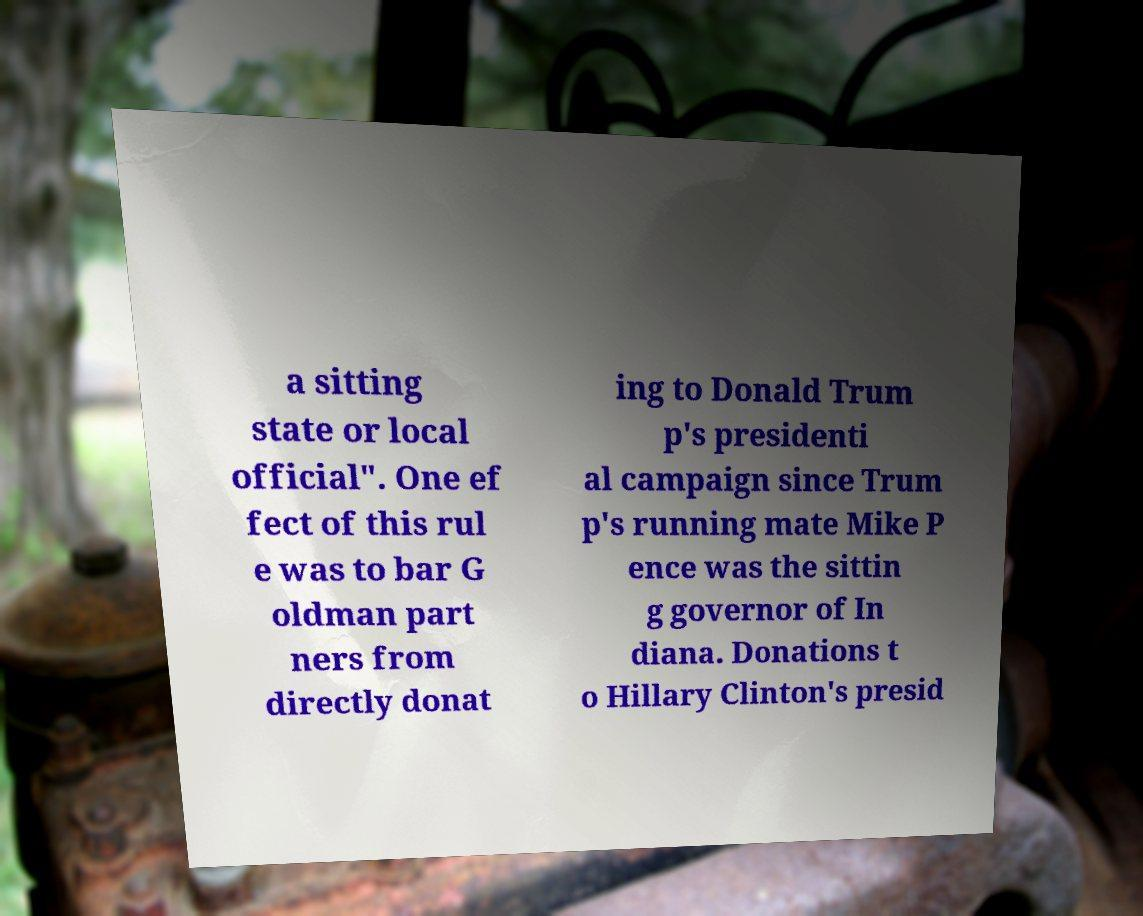Could you assist in decoding the text presented in this image and type it out clearly? a sitting state or local official". One ef fect of this rul e was to bar G oldman part ners from directly donat ing to Donald Trum p's presidenti al campaign since Trum p's running mate Mike P ence was the sittin g governor of In diana. Donations t o Hillary Clinton's presid 